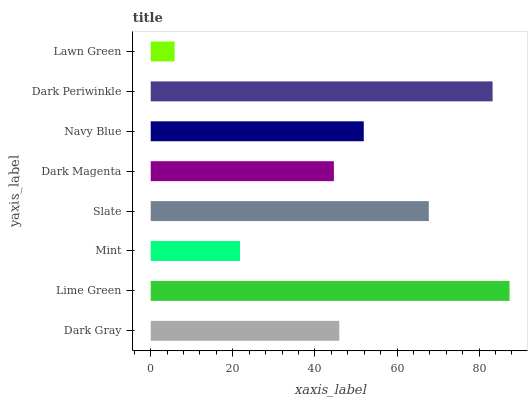Is Lawn Green the minimum?
Answer yes or no. Yes. Is Lime Green the maximum?
Answer yes or no. Yes. Is Mint the minimum?
Answer yes or no. No. Is Mint the maximum?
Answer yes or no. No. Is Lime Green greater than Mint?
Answer yes or no. Yes. Is Mint less than Lime Green?
Answer yes or no. Yes. Is Mint greater than Lime Green?
Answer yes or no. No. Is Lime Green less than Mint?
Answer yes or no. No. Is Navy Blue the high median?
Answer yes or no. Yes. Is Dark Gray the low median?
Answer yes or no. Yes. Is Dark Gray the high median?
Answer yes or no. No. Is Slate the low median?
Answer yes or no. No. 